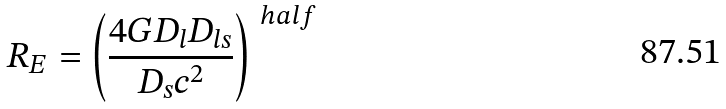Convert formula to latex. <formula><loc_0><loc_0><loc_500><loc_500>R _ { E } = \left ( \frac { 4 G D _ { l } D _ { l s } } { D _ { s } c ^ { 2 } } \right ) ^ { \ h a l f }</formula> 